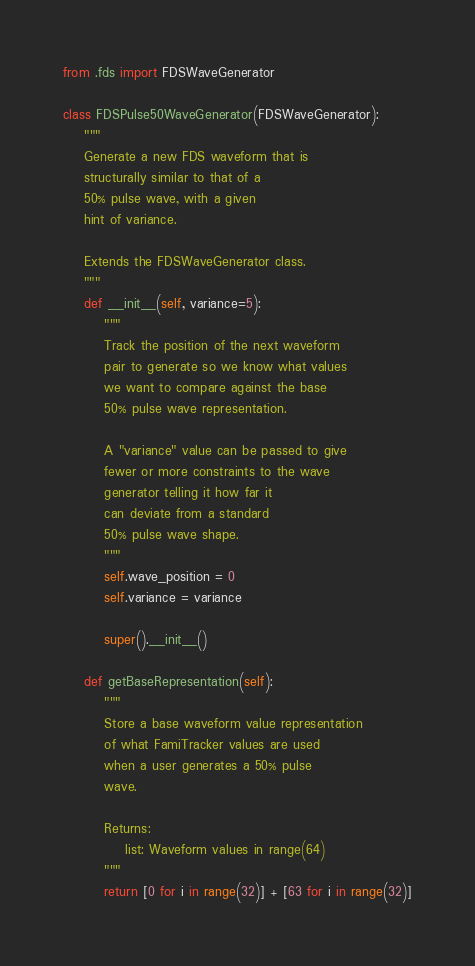Convert code to text. <code><loc_0><loc_0><loc_500><loc_500><_Python_>from .fds import FDSWaveGenerator

class FDSPulse50WaveGenerator(FDSWaveGenerator):
    """
    Generate a new FDS waveform that is 
    structurally similar to that of a 
    50% pulse wave, with a given 
    hint of variance.

    Extends the FDSWaveGenerator class.
    """
    def __init__(self, variance=5):
        """
        Track the position of the next waveform
        pair to generate so we know what values 
        we want to compare against the base 
        50% pulse wave representation.

        A "variance" value can be passed to give
        fewer or more constraints to the wave
        generator telling it how far it
        can deviate from a standard
        50% pulse wave shape.
        """
        self.wave_position = 0
        self.variance = variance

        super().__init__()

    def getBaseRepresentation(self):
        """
        Store a base waveform value representation
        of what FamiTracker values are used
        when a user generates a 50% pulse 
        wave.

        Returns:
            list: Waveform values in range(64)
        """
        return [0 for i in range(32)] + [63 for i in range(32)]
</code> 